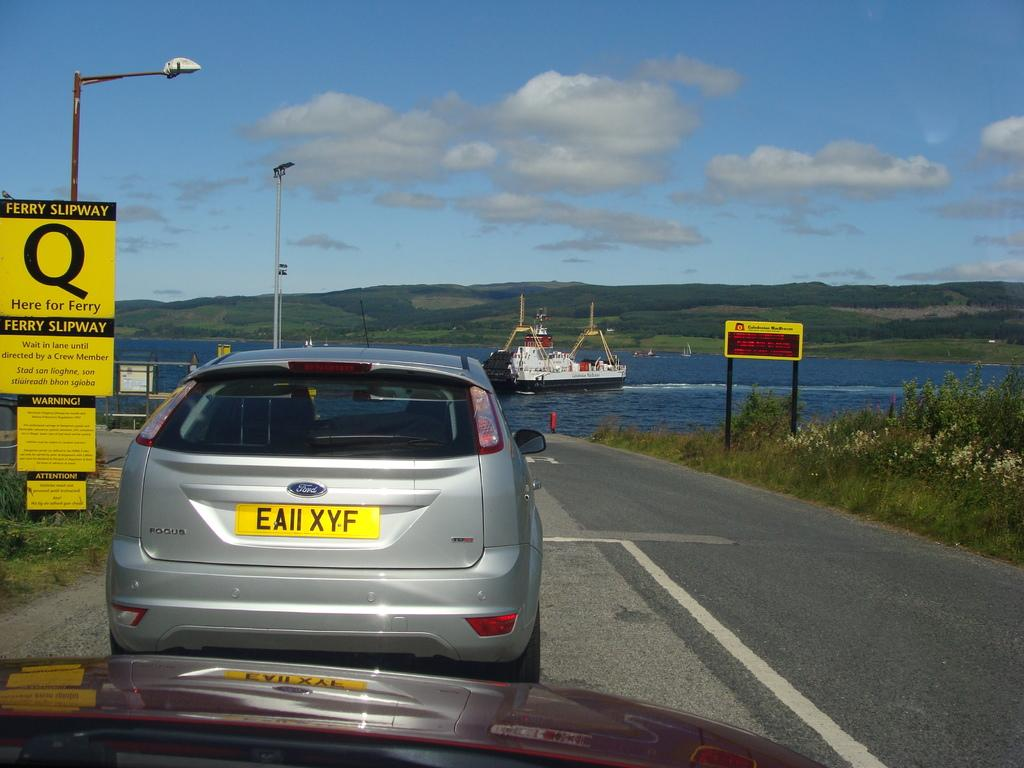How many vehicles are on the road in the image? There are two vehicles on the road in the image. What is attached to the poles in the image? Boards and lights are attached to poles in the image. What type of vegetation is present in the image? Grass and plants are visible in the image. What is located on the water in the image? There is a ship on the water in the image. What can be seen in the background of the image? Hills and the sky are visible in the background of the image. What type of voyage is the ship embarking on in the image? There is no indication of a voyage in the image; it simply shows a ship on the water. What connection can be made between the hills and the sky in the image? There is no direct connection between the hills and the sky in the image; they are simply two separate elements in the background. 